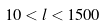<formula> <loc_0><loc_0><loc_500><loc_500>1 0 < l < 1 5 0 0</formula> 